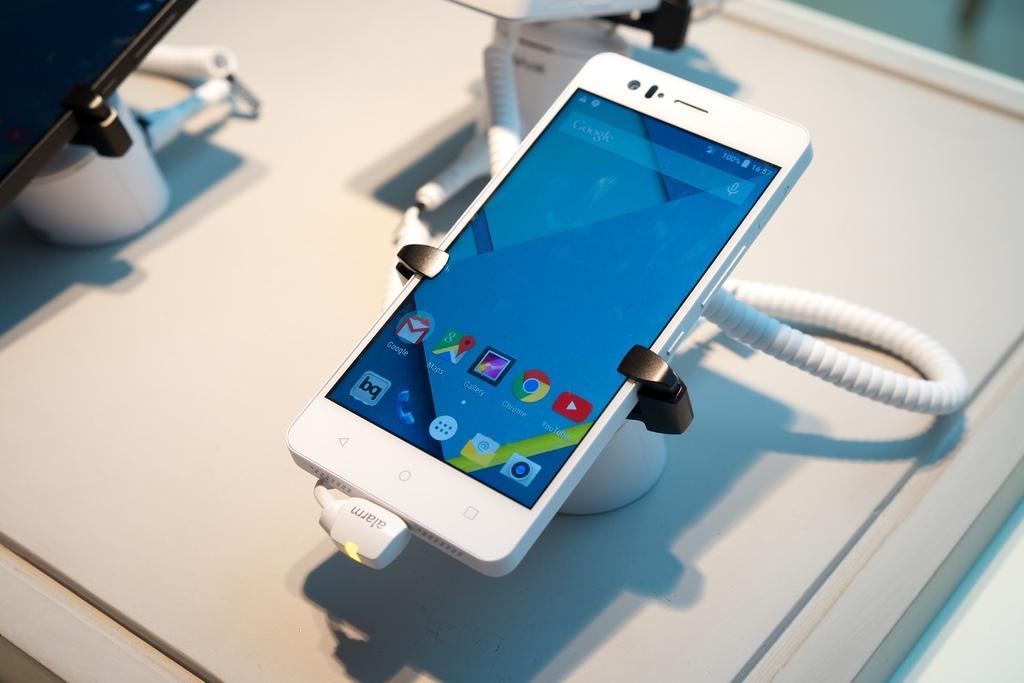How would you summarize this image in a sentence or two? The picture consists of a table, on the table there are electronic gadgets, charging cables and other objects. 